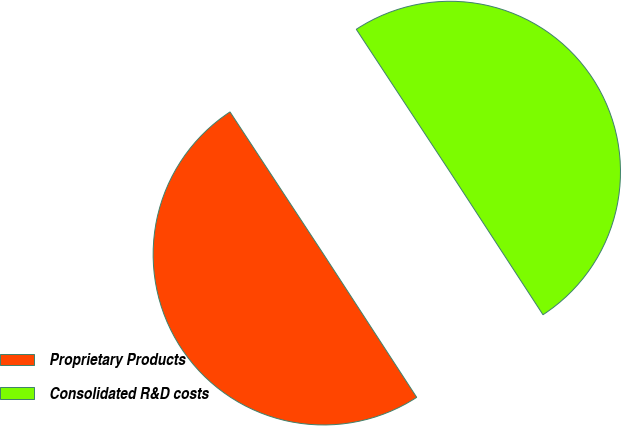Convert chart to OTSL. <chart><loc_0><loc_0><loc_500><loc_500><pie_chart><fcel>Proprietary Products<fcel>Consolidated R&D costs<nl><fcel>49.93%<fcel>50.07%<nl></chart> 